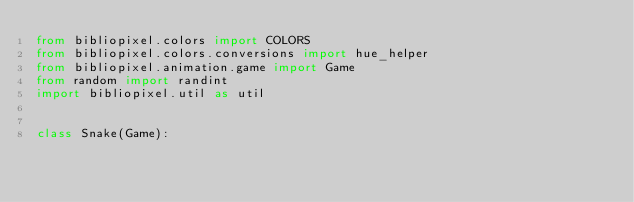Convert code to text. <code><loc_0><loc_0><loc_500><loc_500><_Python_>from bibliopixel.colors import COLORS
from bibliopixel.colors.conversions import hue_helper
from bibliopixel.animation.game import Game
from random import randint
import bibliopixel.util as util


class Snake(Game):
</code> 